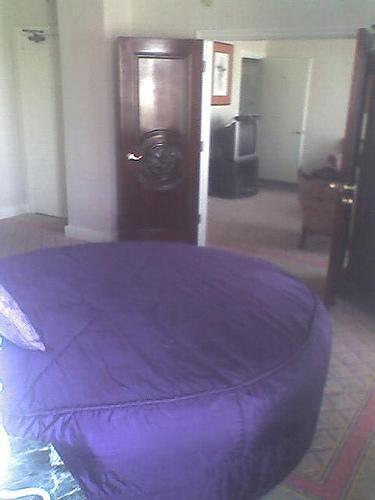How many doors are open?
Give a very brief answer. 2. How many chairs are facing the far wall?
Give a very brief answer. 0. 